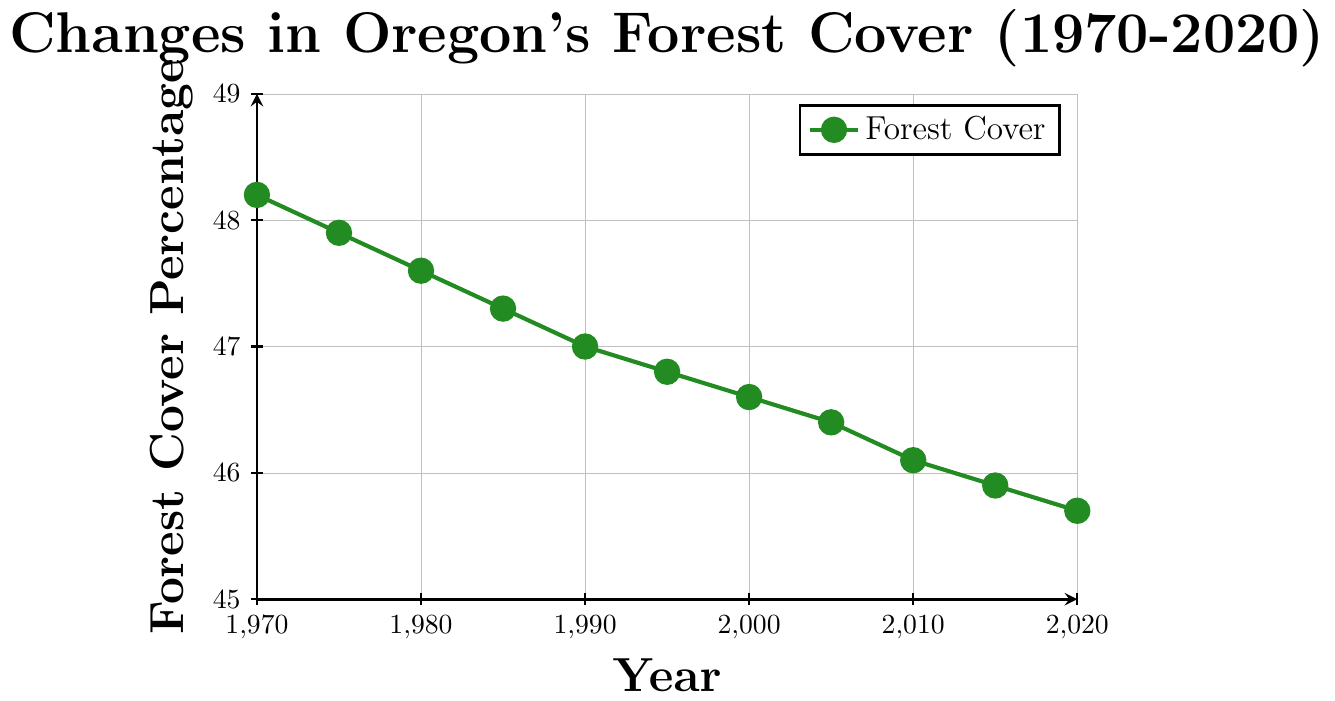What is the forest cover percentage in 1970? Look at the data point where the year is 1970 and observe the corresponding forest cover percentage.
Answer: 48.2 How did the forest cover percentage change from 1970 to 2020? Subtract the forest cover percentage in 2020 from that in 1970: 48.2 - 45.7.
Answer: -2.5 Between which consecutive years did Oregon's forest cover decrease the most? Calculate the differences between consecutive years and find the maximum decrease. (47.6 - 47.3 = 0.3, ...) The largest decrease is between 1975 and 1980.
Answer: 1975-1980 What is the average forest cover percentage over the entire period? Sum all the forest cover percentages and divide by the number of years: (48.2 + 47.9 + 47.6 + 47.3 + 47.0 + 46.8 + 46.6 + 46.4 + 46.1 + 45.9 + 45.7) / 11.
Answer: 46.92 Which year had the closest forest cover percentage to the average over the entire period? Calculate the average forest cover and find the year with the smallest difference from this average: 46.92 (47.0 - 46.92 = 0.08, ...) The closest year is 1990.
Answer: 1990 How many times did the forest cover decrease from one recorded year to the next? Count the number of times the forest cover percentage is lower than the previous value: All transitions are decreases: 10 times.
Answer: 10 In which decade did Oregon experience the largest average annual decrease in forest cover? Calculate the average decrease per year for each decade and compare them: the 1970s, 1980s, etc. The largest decrease is in the 1980s.
Answer: 1980s What was the percent decrease in forest cover from 2000 to 2020? Calculate the difference between the forest covers in 2000 and 2020, then divide by the value in 2000 and multiply by 100: ((46.6 - 45.7) / 46.6) * 100.
Answer: 1.93% Was there any period where the forest cover remained constant? Check the forest cover percentages for consecutive years to see if any values are the same. None of the values are equal, so it was never constant.
Answer: No 